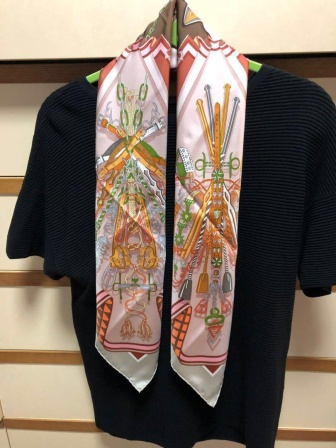What if the objects on the scarf were magical symbols? Imagine a world where each object on the scarf represents a magical symbol, bestowing special powers upon the wearer. The teapot, when touched, could brew the perfect cup of tea that imparts wisdom. The vase could conjure a bouquet of flowers, each with healing properties. The basket could summon a picnic feast, nourishing both body and soul. This enchanted scarf was whispered to be the creation of an ancient sorcerer who believed in blending beauty with magic. Passed down through generations, the scarf finds itself draped over the sweater, waiting for someone with a pure heart to unlock its secrets and harness its powers for good. 